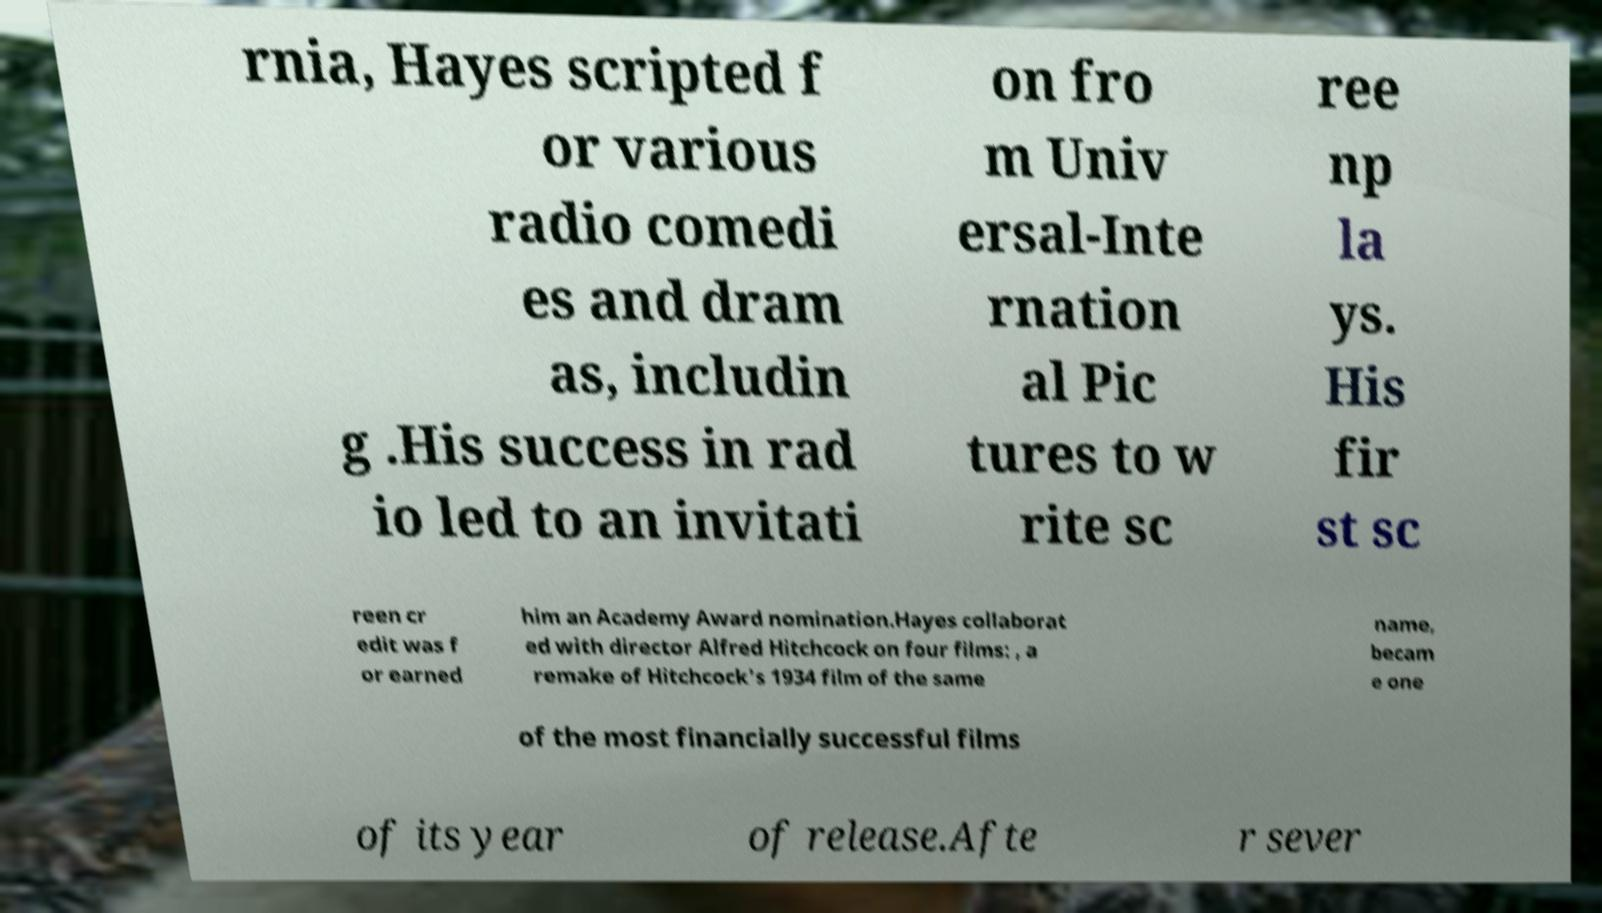Could you assist in decoding the text presented in this image and type it out clearly? rnia, Hayes scripted f or various radio comedi es and dram as, includin g .His success in rad io led to an invitati on fro m Univ ersal-Inte rnation al Pic tures to w rite sc ree np la ys. His fir st sc reen cr edit was f or earned him an Academy Award nomination.Hayes collaborat ed with director Alfred Hitchcock on four films: , a remake of Hitchcock's 1934 film of the same name, becam e one of the most financially successful films of its year of release.Afte r sever 